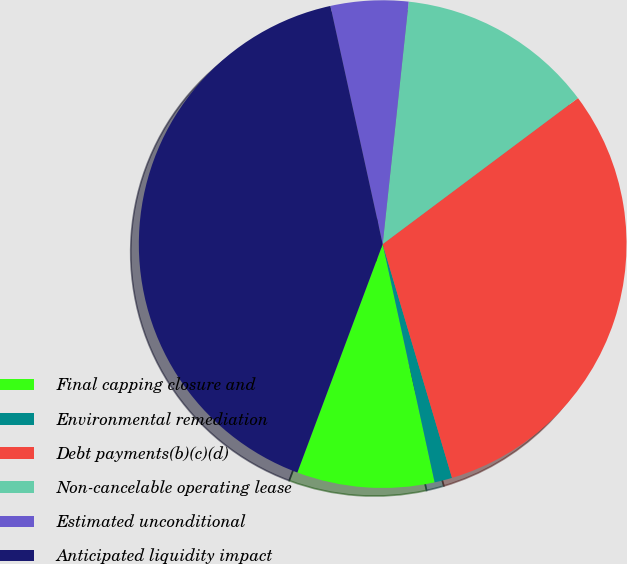<chart> <loc_0><loc_0><loc_500><loc_500><pie_chart><fcel>Final capping closure and<fcel>Environmental remediation<fcel>Debt payments(b)(c)(d)<fcel>Non-cancelable operating lease<fcel>Estimated unconditional<fcel>Anticipated liquidity impact<nl><fcel>9.11%<fcel>1.17%<fcel>30.63%<fcel>13.08%<fcel>5.14%<fcel>40.87%<nl></chart> 